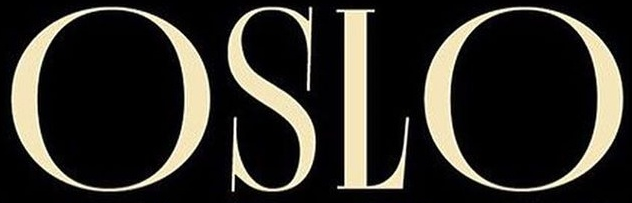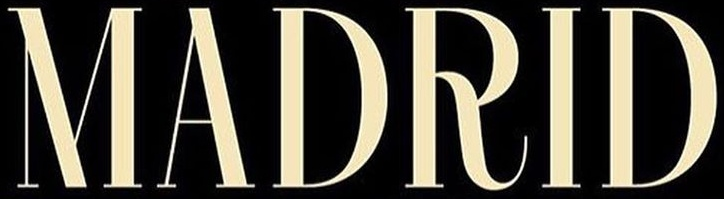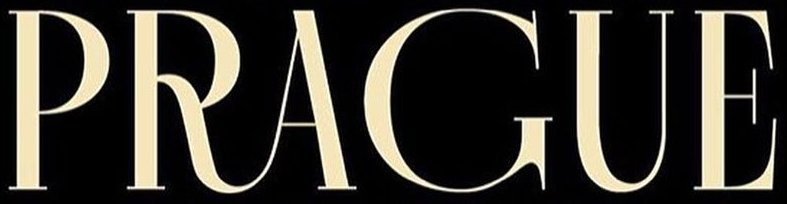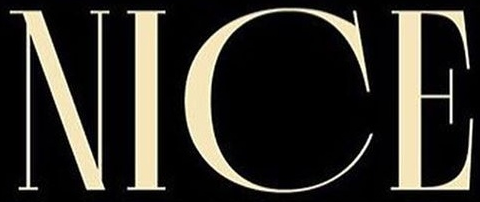Identify the words shown in these images in order, separated by a semicolon. OSLO; MADRID; PRAGUE; NICE 